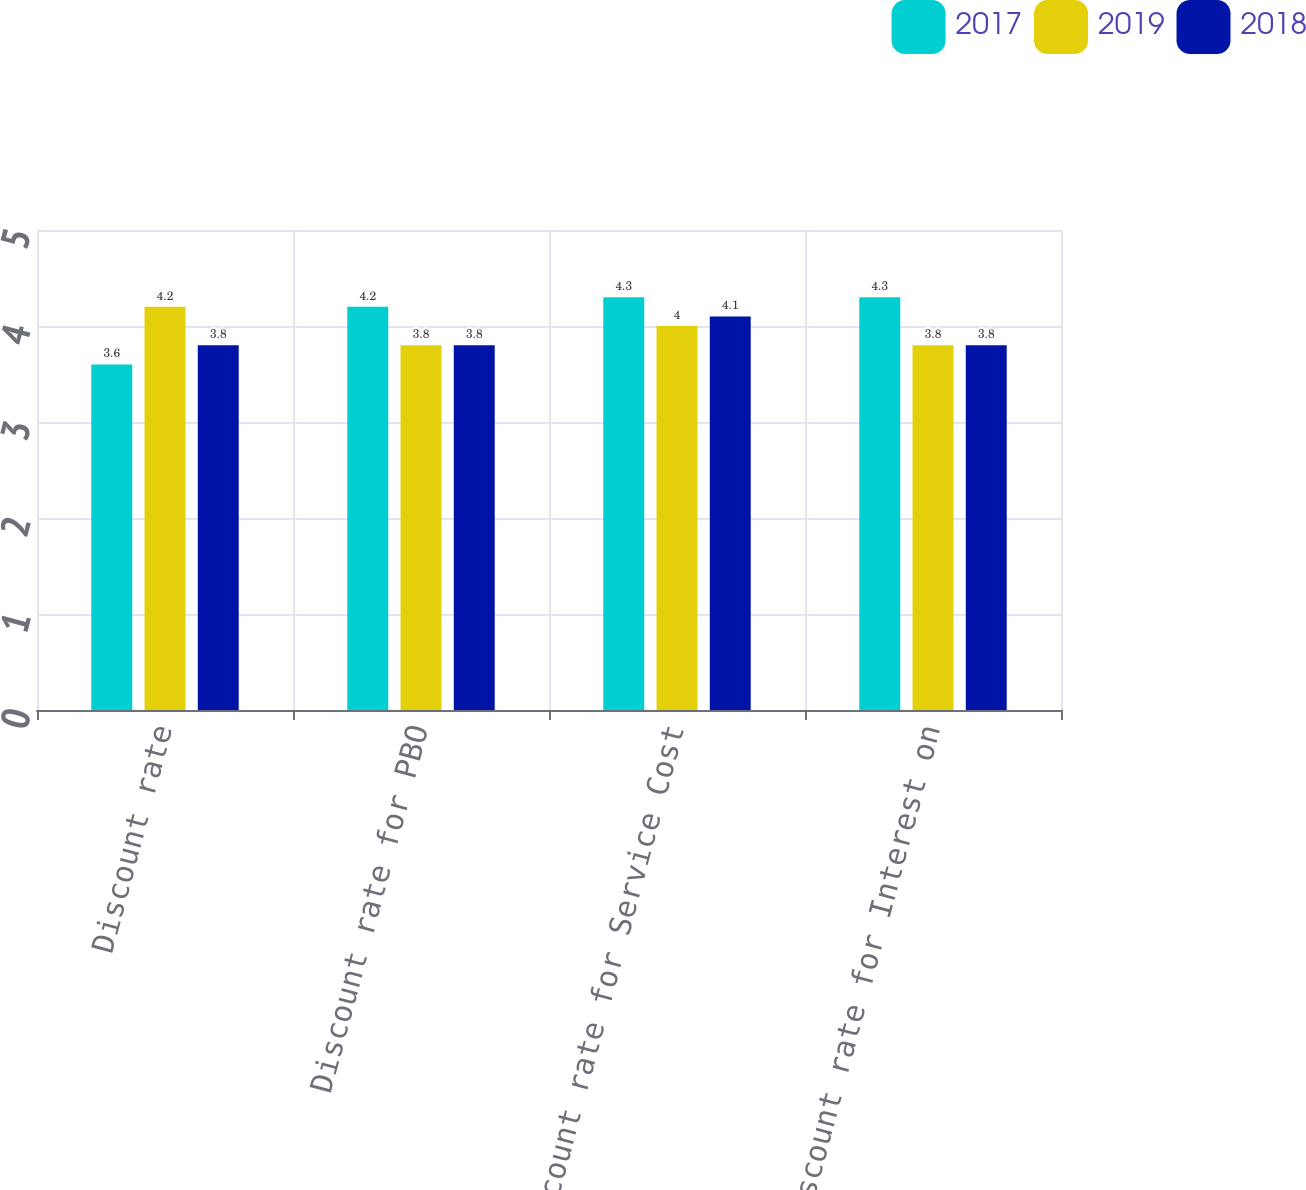<chart> <loc_0><loc_0><loc_500><loc_500><stacked_bar_chart><ecel><fcel>Discount rate<fcel>Discount rate for PBO<fcel>Discount rate for Service Cost<fcel>Discount rate for Interest on<nl><fcel>2017<fcel>3.6<fcel>4.2<fcel>4.3<fcel>4.3<nl><fcel>2019<fcel>4.2<fcel>3.8<fcel>4<fcel>3.8<nl><fcel>2018<fcel>3.8<fcel>3.8<fcel>4.1<fcel>3.8<nl></chart> 